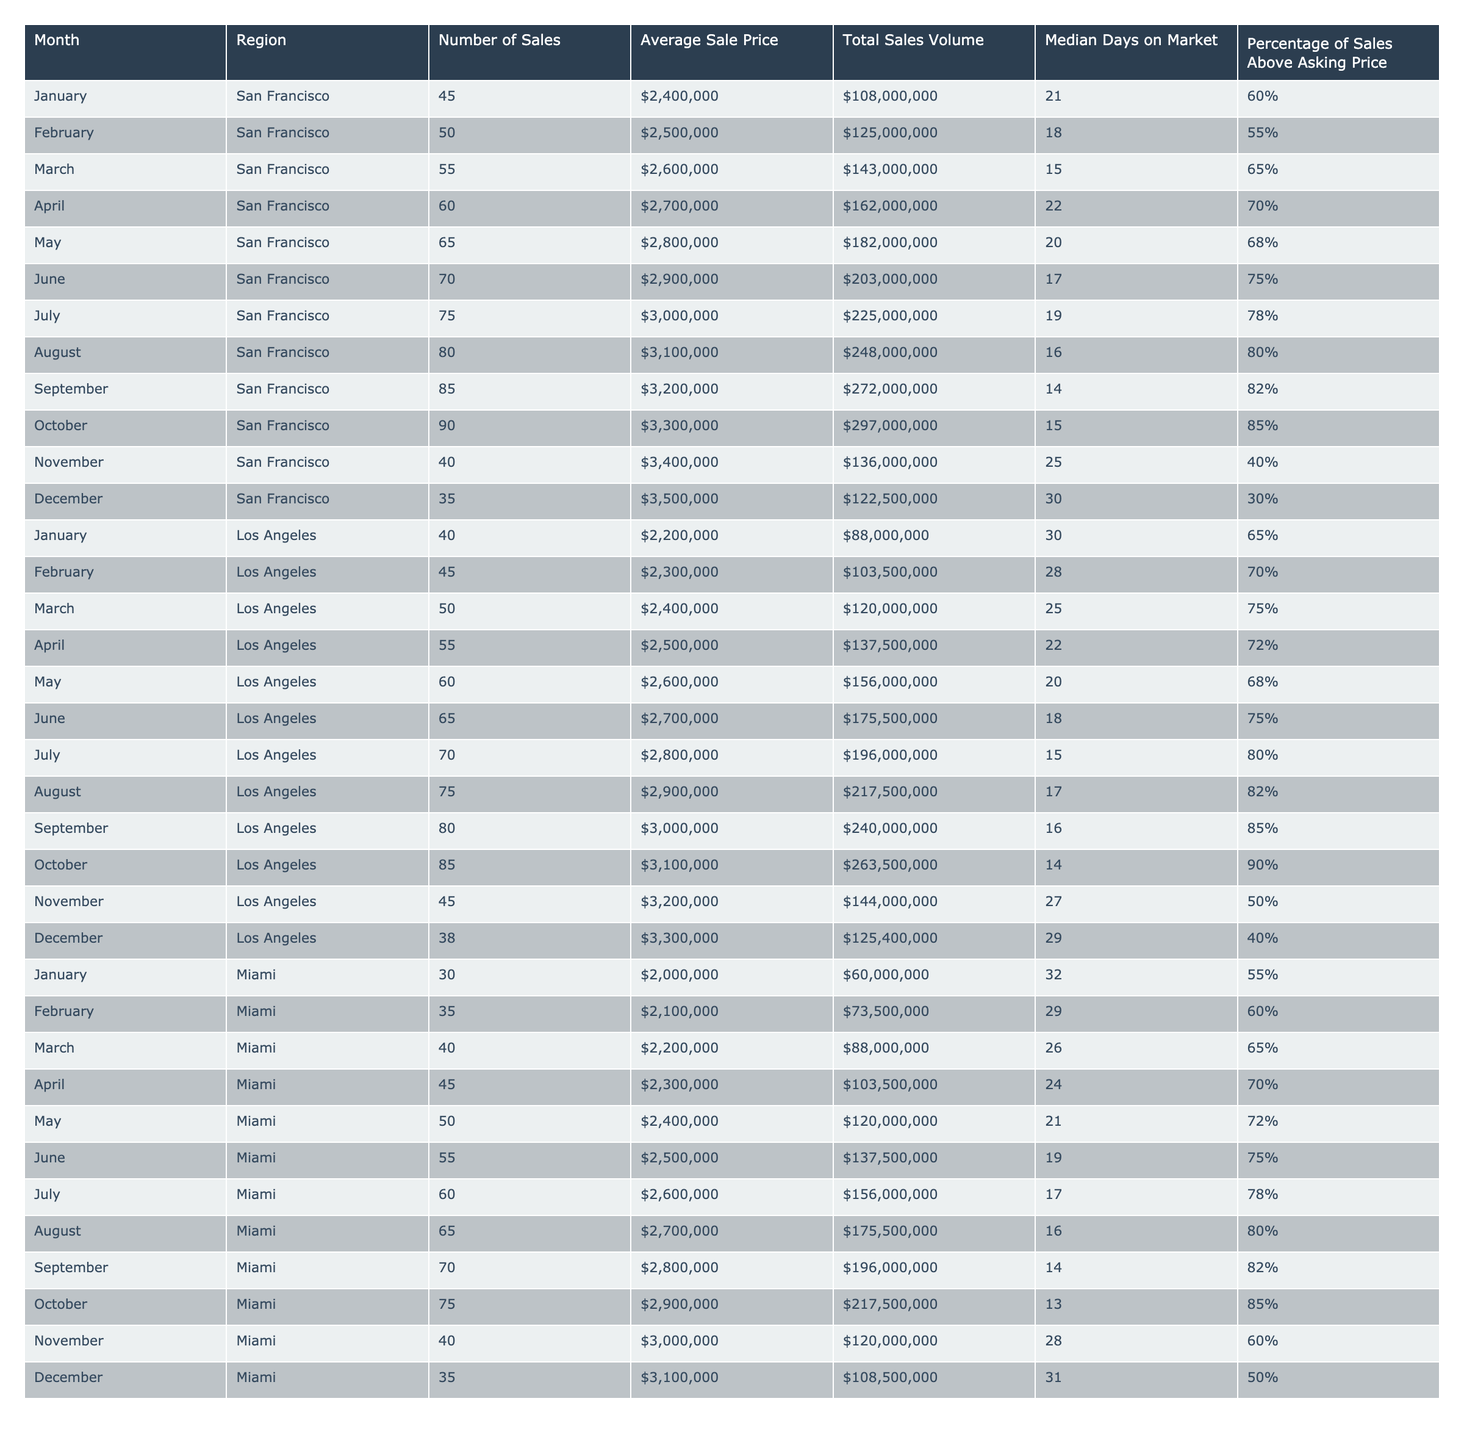What was the total sales volume in San Francisco for March? The total sales volume for San Francisco in March is listed in the table as $143,000,000.
Answer: $143,000,000 How many homes were sold in Miami in July? The number of homes sold in Miami for July is provided as 60 in the table.
Answer: 60 What is the average sale price of luxury homes in Los Angeles in October? In the table, the average sale price for Los Angeles in October is noted as $3,100,000.
Answer: $3,100,000 In which month did San Francisco have the highest number of sales? By reviewing the numbers, July has the highest sales at 75, compared to other months.
Answer: July What is the median days on market for luxury homes sold in November in San Francisco? The median days on market for November in San Francisco is specified as 25 days in the table.
Answer: 25 days What is the percentage of sales above asking price in Los Angeles for September? The table indicates that the percentage of sales above asking price in Los Angeles for September is 85%.
Answer: 85% Which region had the lowest average sale price in February? By comparing the average sale prices for February, Miami has the lowest average sale price of $2,100,000.
Answer: Miami How many more homes were sold in San Francisco in August compared to December? San Francisco sold 80 homes in August and 35 in December; therefore, 80 - 35 = 45 more homes.
Answer: 45 more homes Were there any months in Miami where the percentage of sales above asking price was below 60%? Yes, in both November and December, the percentages were 60% and 50%, respectively, which are below 60%.
Answer: Yes What is the average sale price of luxury homes in Los Angeles for the first half of the year? The average sale prices from January to June are $2,200,000, $2,300,000, $2,400,000, $2,500,000, $2,600,000, and $2,700,000. Their total is $14,000,000, and the average is $14,000,000 / 6 = $2,333,333.
Answer: $2,333,333 If we compare the total sales volume of luxury homes in San Francisco to Miami for the entire year, which region had a higher total? The total sales volumes for San Francisco and Miami are $1,408,500,000 and $1,491,500,000, respectively. Since $1,491,500,000 is higher, Miami had more.
Answer: Miami had a higher total 